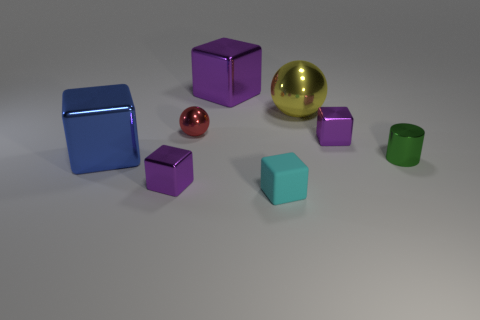How many purple cubes must be subtracted to get 1 purple cubes? 2 Subtract all small shiny cubes. How many cubes are left? 3 Subtract all gray cylinders. How many purple blocks are left? 3 Add 1 small matte objects. How many objects exist? 9 Subtract all cyan blocks. How many blocks are left? 4 Subtract all cubes. How many objects are left? 3 Subtract all purple balls. Subtract all blue cylinders. How many balls are left? 2 Add 8 big blue metal blocks. How many big blue metal blocks are left? 9 Add 5 tiny cylinders. How many tiny cylinders exist? 6 Subtract 1 red spheres. How many objects are left? 7 